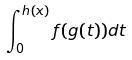Convert formula to latex. <formula><loc_0><loc_0><loc_500><loc_500>\int _ { 0 } ^ { h ( x ) } f ( g ( t ) ) d t</formula> 